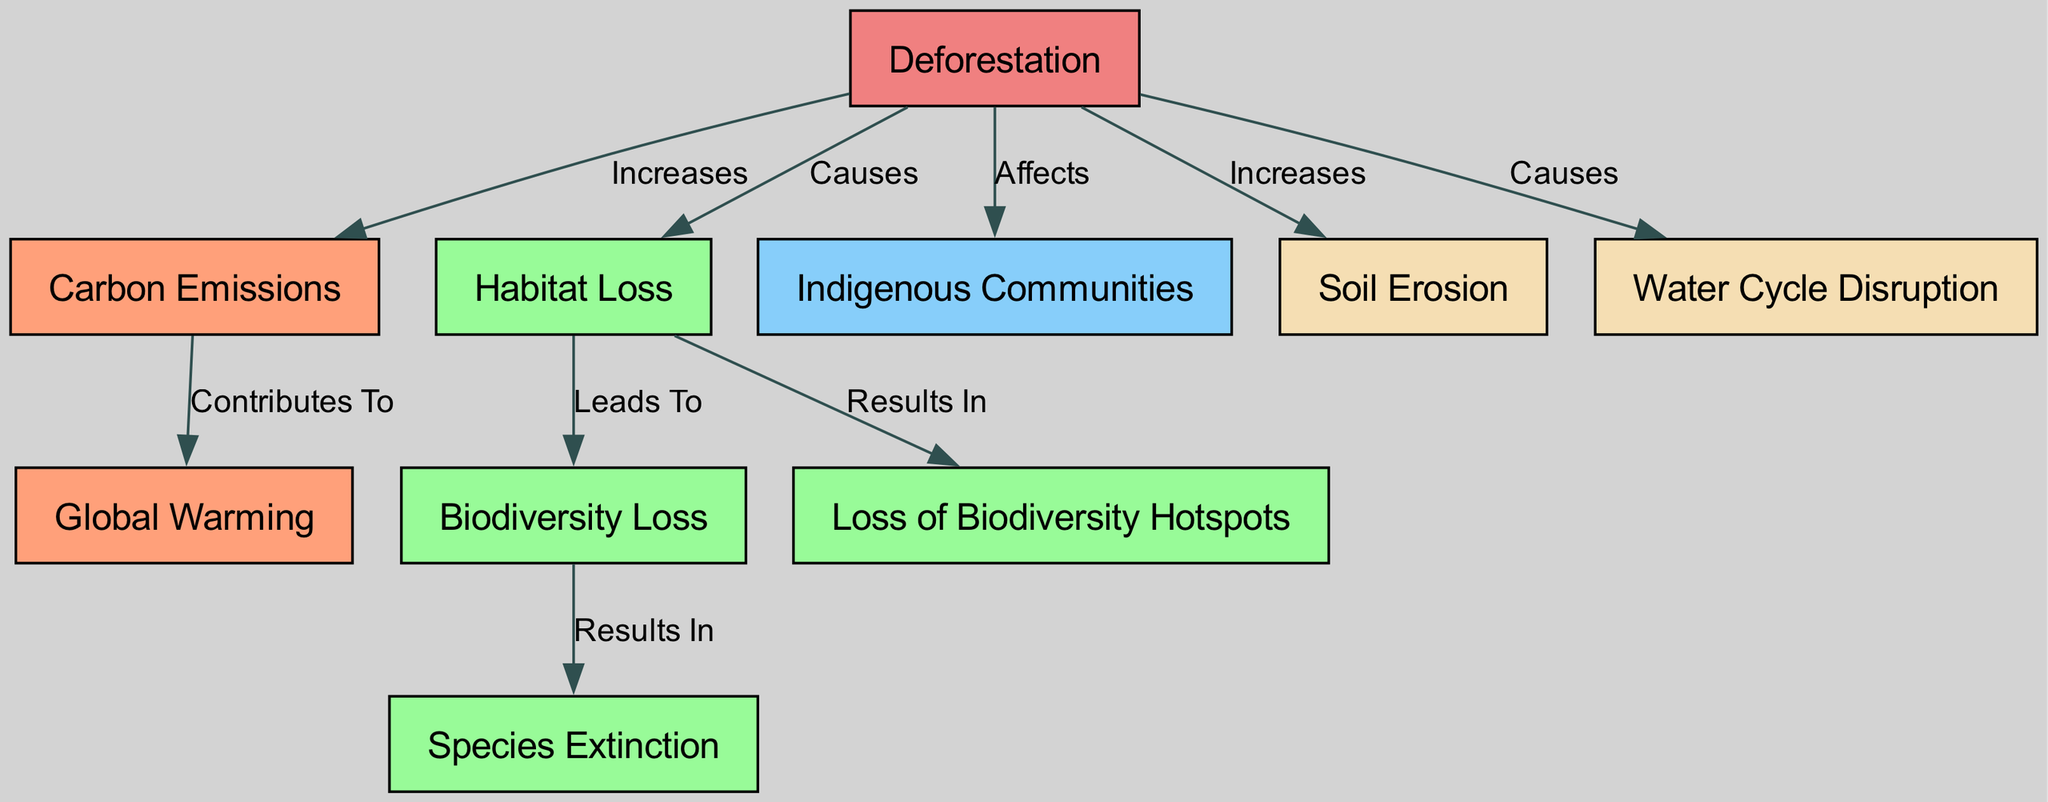What is the central cause of the issues shown in the diagram? The diagram shows that Deforestation is the central node and is labeled as the cause of various environmental impacts like Carbon Emissions, Habitat Loss, and Water Cycle Disruption.
Answer: Deforestation How many total nodes are depicted in the diagram? By reviewing the nodes listed, we can count them: Deforestation, Carbon Emissions, Habitat Loss, Biodiversity Loss, Indigenous Communities, Global Warming, Species Extinction, Soil Erosion, Water Cycle Disruption, and Loss of Biodiversity Hotspots, which totals to ten nodes.
Answer: 10 What does Deforestation contribute to according to the diagram? The diagram indicates that Deforestation increases Carbon Emissions, which contributes to Global Warming. The flow from Deforestation to Carbon Emissions and then to Global Warming illustrates this relationship.
Answer: Global Warming Which nodes are affected by Habitat Loss as shown in the diagram? Habitat Loss is linked to two nodes: it leads to Biodiversity Loss and also results in Loss of Biodiversity Hotspots, as indicated by the labels on the edges connecting these nodes.
Answer: Biodiversity Loss, Loss of Biodiversity Hotspots What is the relationship between Biodiversity Loss and Species Extinction? The diagram shows that Biodiversity Loss leads to Species Extinction, represented by the directed edge labeled "Results In," indicating a direct connection whereby the loss of biodiversity inevitably results in extinctions.
Answer: Leads To 